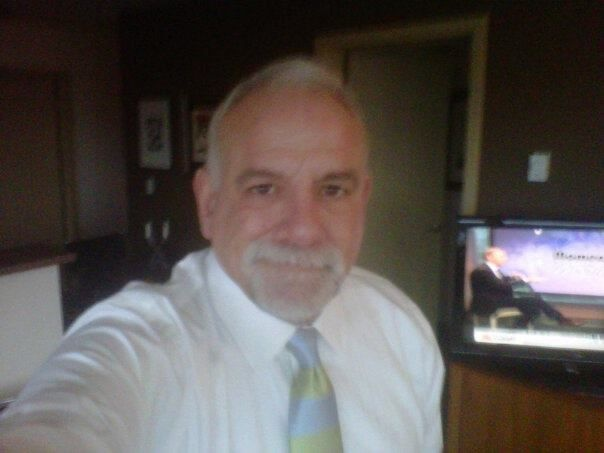Describe the objects in this image and their specific colors. I can see people in black, darkgray, gray, and lightgray tones, tv in black, lavender, gray, and darkgray tones, and tie in black, darkgray, and gray tones in this image. 